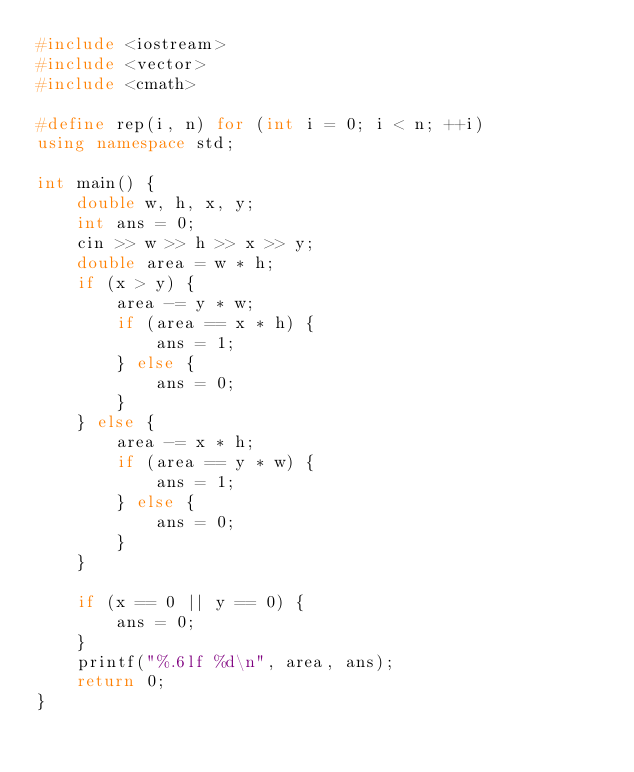Convert code to text. <code><loc_0><loc_0><loc_500><loc_500><_C++_>#include <iostream>
#include <vector>
#include <cmath>

#define rep(i, n) for (int i = 0; i < n; ++i)
using namespace std;

int main() {
    double w, h, x, y;
    int ans = 0;
    cin >> w >> h >> x >> y;
    double area = w * h;
    if (x > y) {
        area -= y * w;
        if (area == x * h) {
            ans = 1;
        } else {
            ans = 0;
        }
    } else {
        area -= x * h;
        if (area == y * w) {
            ans = 1;
        } else {
            ans = 0;
        }
    }

    if (x == 0 || y == 0) {
        ans = 0;
    }
    printf("%.6lf %d\n", area, ans);
    return 0;
}
</code> 